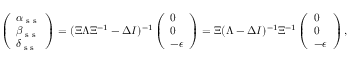<formula> <loc_0><loc_0><loc_500><loc_500>\left ( \begin{array} { l } { \alpha _ { s s } } \\ { \beta _ { s s } } \\ { \delta _ { s s } } \end{array} \right ) = ( \Xi \Lambda \Xi ^ { - 1 } - \Delta I ) ^ { - 1 } \left ( \begin{array} { l } { 0 } \\ { 0 } \\ { - \epsilon } \end{array} \right ) = \Xi ( \Lambda - \Delta I ) ^ { - 1 } \Xi ^ { - 1 } \left ( \begin{array} { l } { 0 } \\ { 0 } \\ { - \epsilon } \end{array} \right ) ,</formula> 